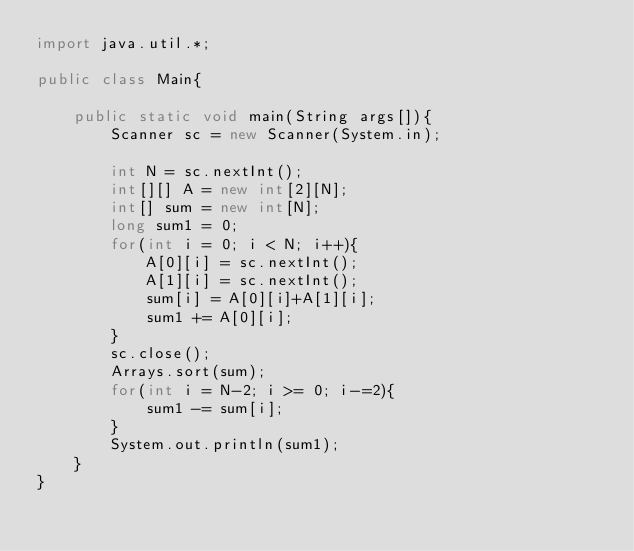<code> <loc_0><loc_0><loc_500><loc_500><_Java_>import java.util.*;

public class Main{
    
    public static void main(String args[]){
        Scanner sc = new Scanner(System.in);
        
        int N = sc.nextInt();
        int[][] A = new int[2][N];
        int[] sum = new int[N];
        long sum1 = 0;
        for(int i = 0; i < N; i++){
            A[0][i] = sc.nextInt();
            A[1][i] = sc.nextInt();
            sum[i] = A[0][i]+A[1][i];
            sum1 += A[0][i];
        }
        sc.close();
        Arrays.sort(sum);
        for(int i = N-2; i >= 0; i-=2){
            sum1 -= sum[i];
        }
        System.out.println(sum1);
    }
}</code> 